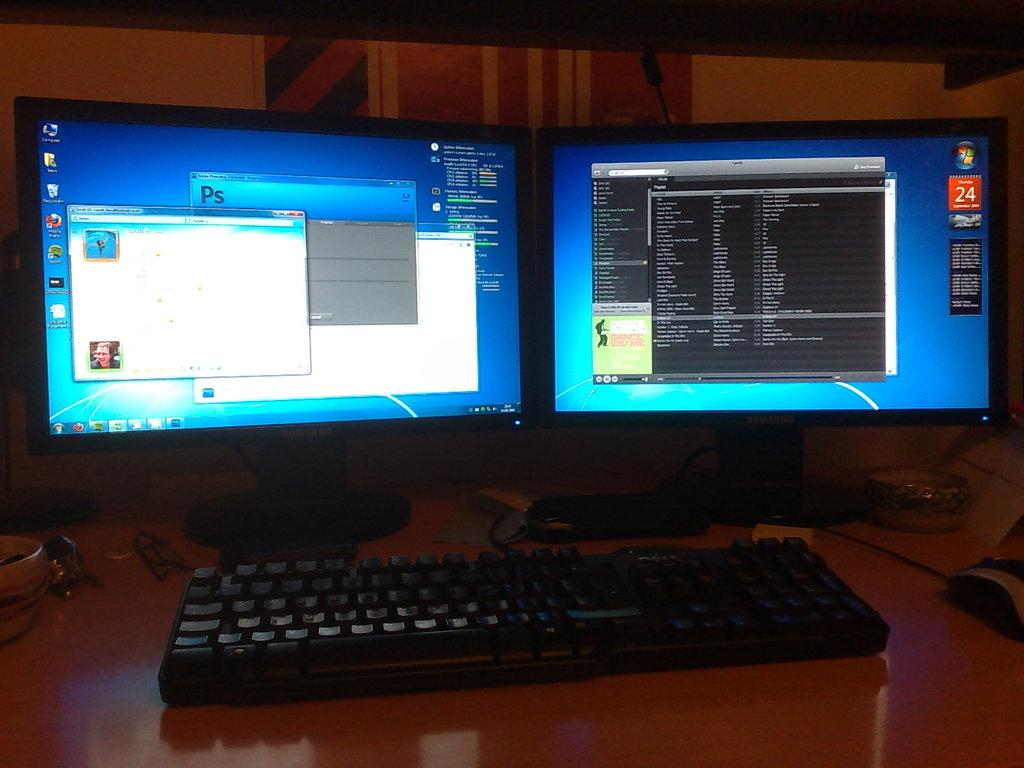Provide a one-sentence caption for the provided image. A computer with two monitors that has Adobe Photoshop open. 